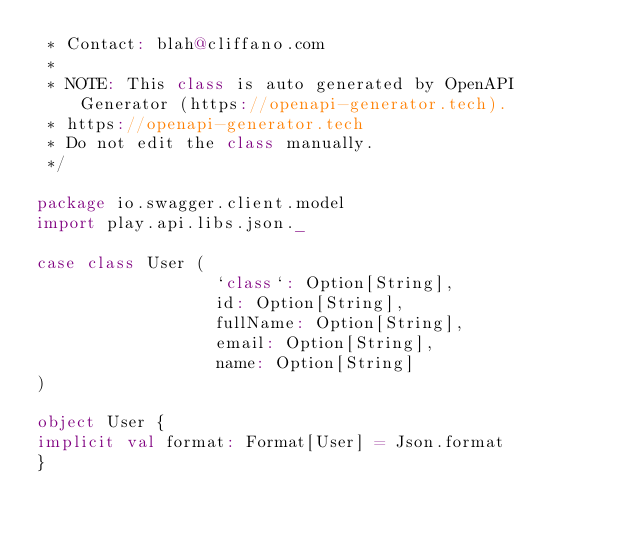<code> <loc_0><loc_0><loc_500><loc_500><_Scala_> * Contact: blah@cliffano.com
 *
 * NOTE: This class is auto generated by OpenAPI Generator (https://openapi-generator.tech).
 * https://openapi-generator.tech
 * Do not edit the class manually.
 */

package io.swagger.client.model
import play.api.libs.json._

case class User (
                  `class`: Option[String],
                  id: Option[String],
                  fullName: Option[String],
                  email: Option[String],
                  name: Option[String]
)

object User {
implicit val format: Format[User] = Json.format
}

</code> 